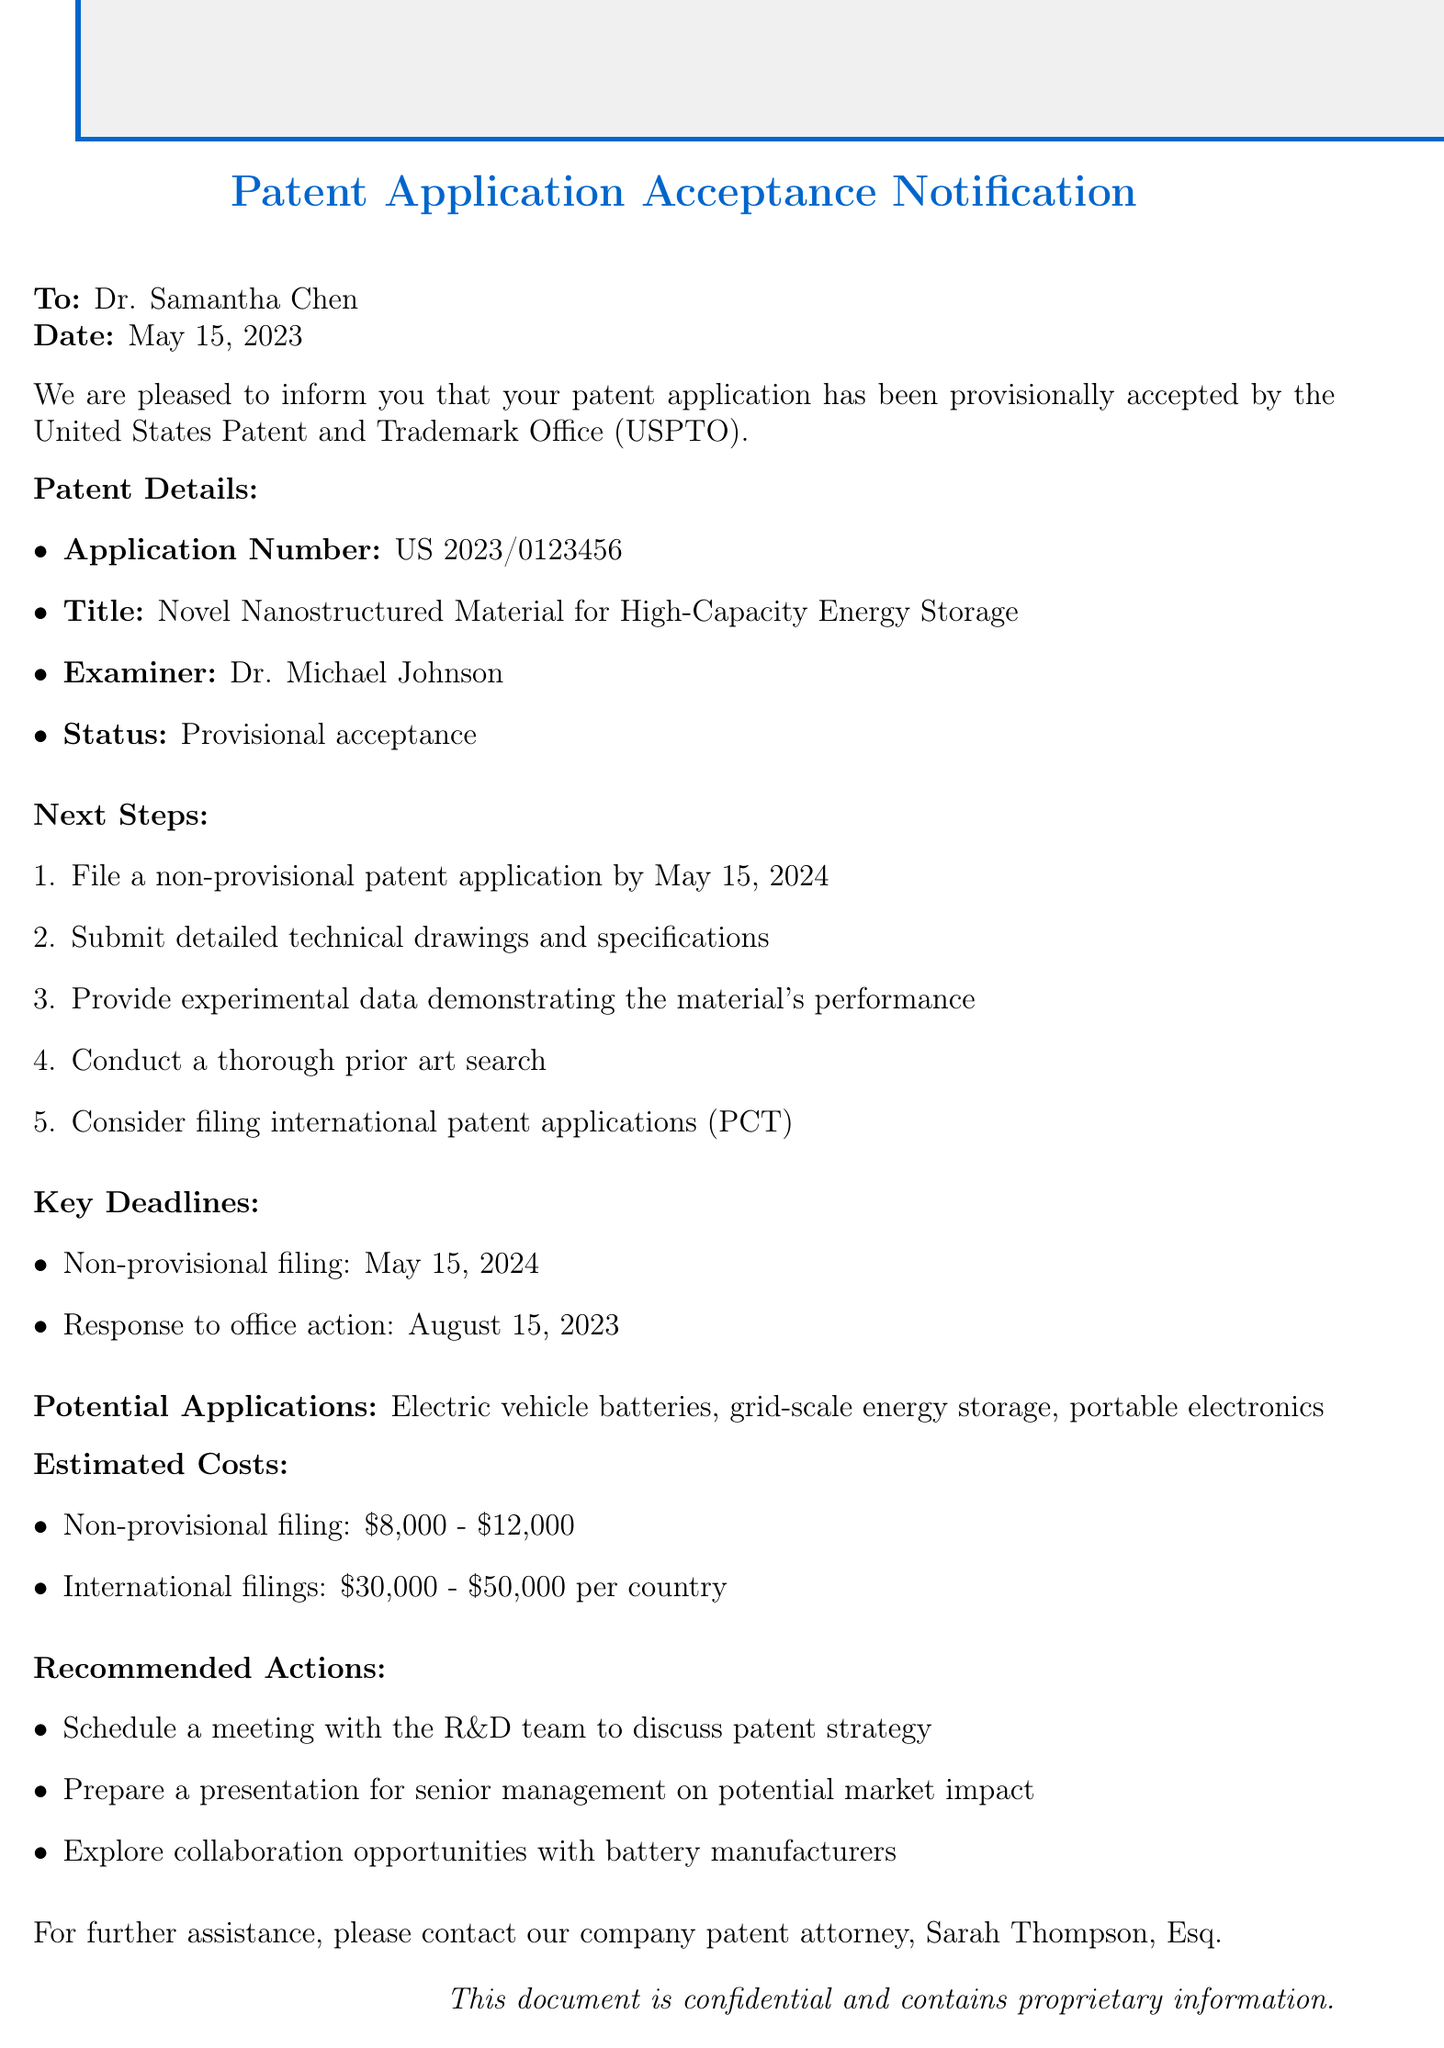What is the patent title? The patent title is explicitly stated in the document, which is "Novel Nanostructured Material for High-Capacity Energy Storage."
Answer: Novel Nanostructured Material for High-Capacity Energy Storage Who is the examiner for the patent application? The document lists the examiner's name as "Dr. Michael Johnson."
Answer: Dr. Michael Johnson What is the acceptance status of the patent application? The acceptance status provided in the document is "Provisional acceptance."
Answer: Provisional acceptance What is the deadline for filing the non-provisional patent application? The document specifies the deadline for the non-provisional patent application as "May 15, 2024."
Answer: May 15, 2024 What is one of the recommended actions mentioned in the document? The document lists recommended actions, one of which is to "Schedule a meeting with the R&D team to discuss patent strategy."
Answer: Schedule a meeting with the R&D team to discuss patent strategy What are the potential applications of the patented material? The document mentions multiple applications, such as "Electric vehicle batteries."
Answer: Electric vehicle batteries How much is the estimated cost for non-provisional filing? The estimated cost for non-provisional filing is clearly stated as "$8,000 - $12,000."
Answer: $8,000 - $12,000 What additional type of patent application should be considered? The document suggests considering "international patent applications (PCT)."
Answer: international patent applications (PCT) What was the notification date of the acceptance? The document provides the notification date as "May 15, 2023."
Answer: May 15, 2023 